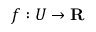<formula> <loc_0><loc_0><loc_500><loc_500>f \colon U \to R</formula> 